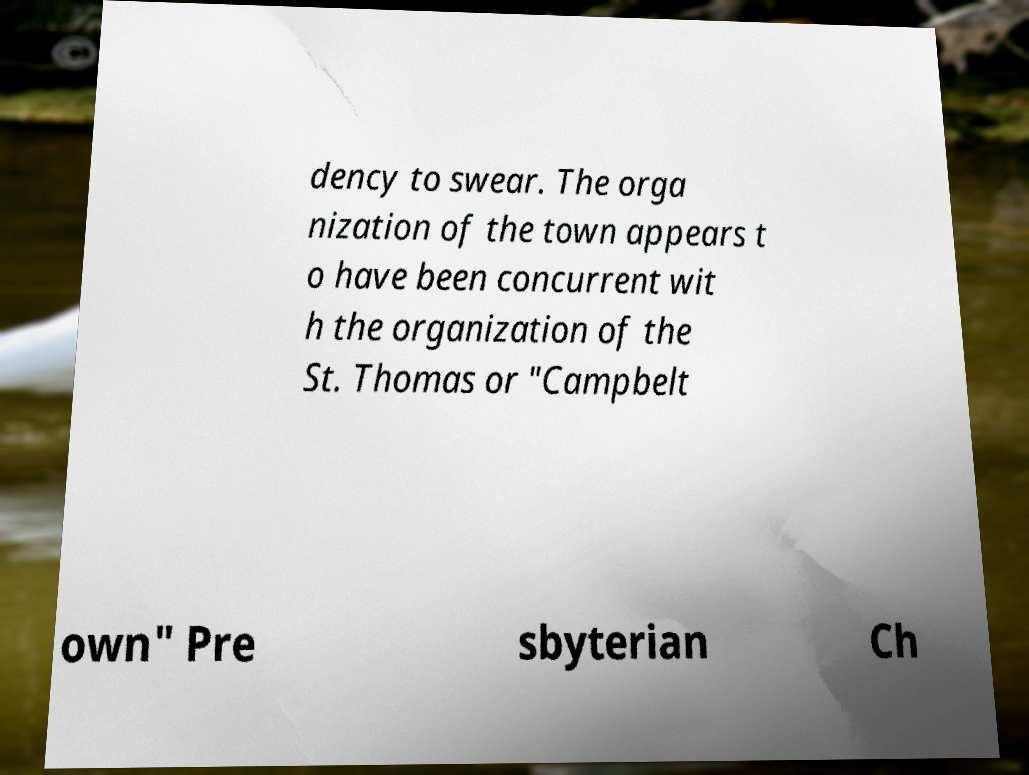I need the written content from this picture converted into text. Can you do that? dency to swear. The orga nization of the town appears t o have been concurrent wit h the organization of the St. Thomas or "Campbelt own" Pre sbyterian Ch 